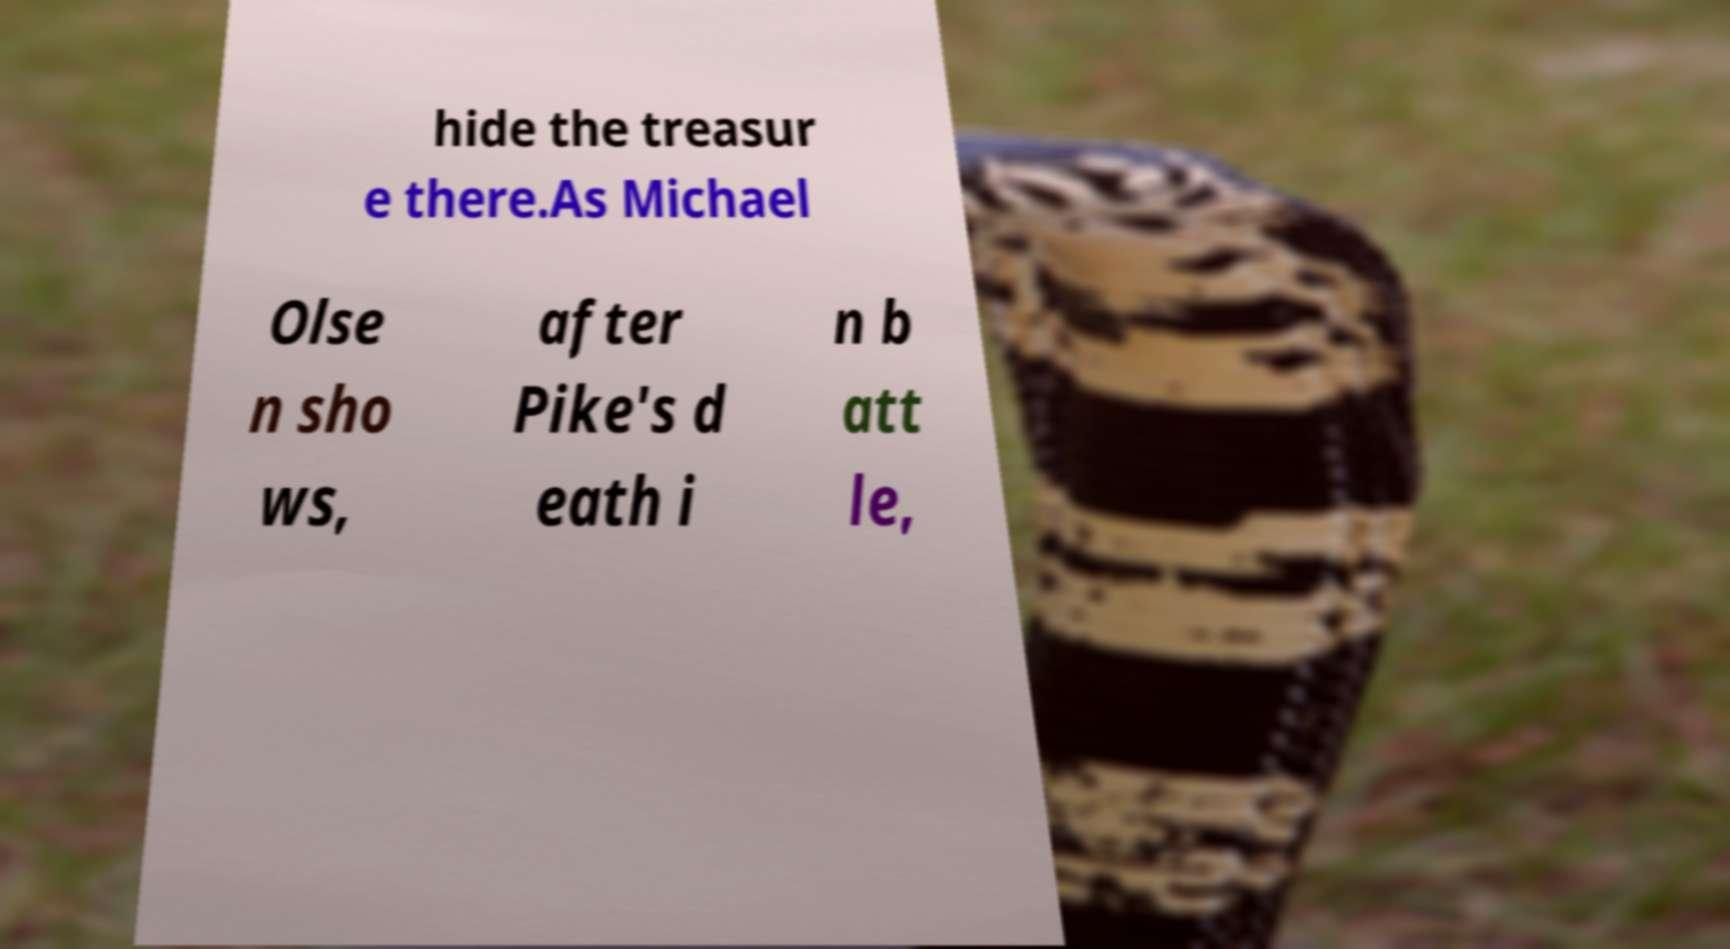There's text embedded in this image that I need extracted. Can you transcribe it verbatim? hide the treasur e there.As Michael Olse n sho ws, after Pike's d eath i n b att le, 